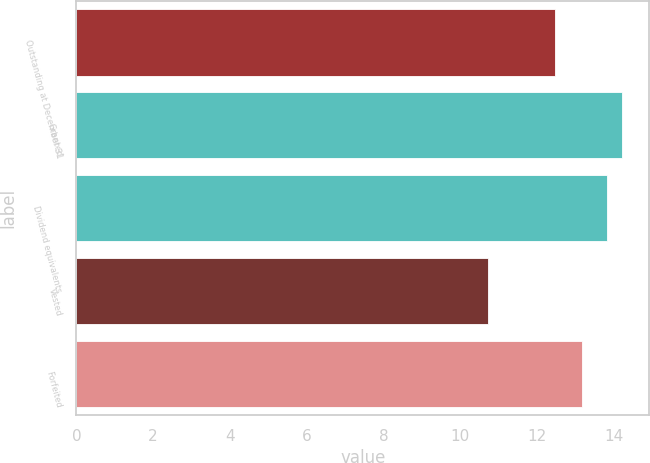Convert chart. <chart><loc_0><loc_0><loc_500><loc_500><bar_chart><fcel>Outstanding at December 31<fcel>Granted<fcel>Dividend equivalents<fcel>Vested<fcel>Forfeited<nl><fcel>12.47<fcel>14.22<fcel>13.83<fcel>10.72<fcel>13.16<nl></chart> 